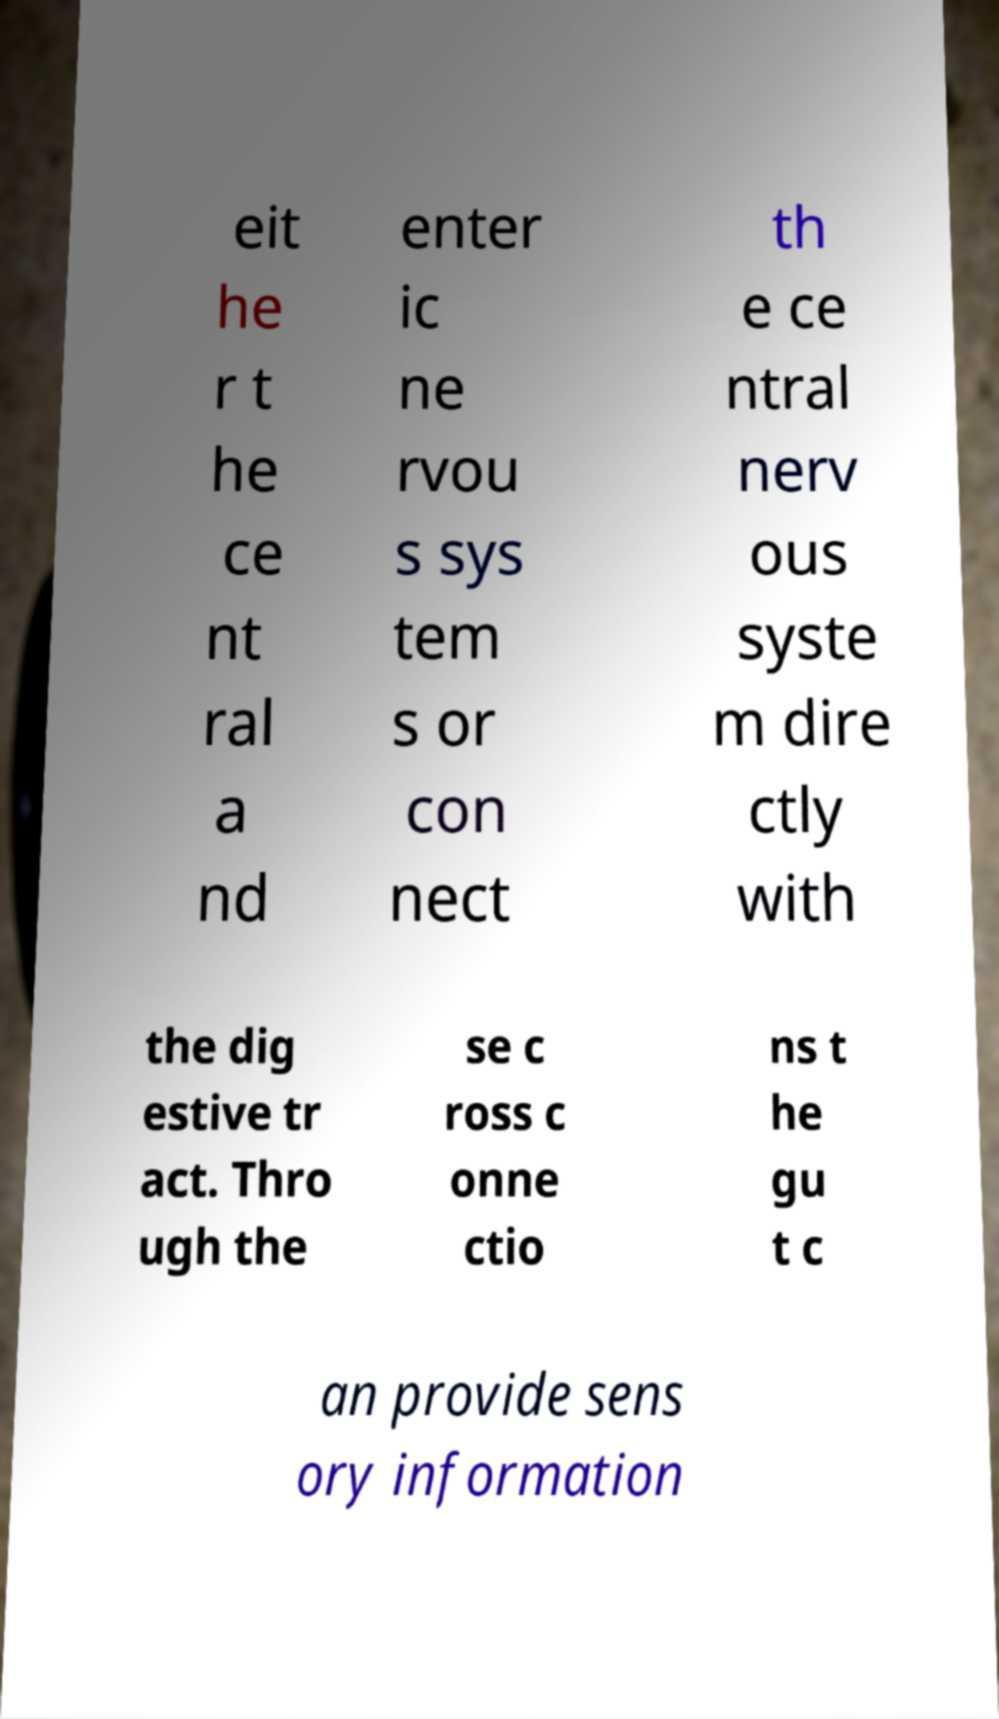Could you assist in decoding the text presented in this image and type it out clearly? eit he r t he ce nt ral a nd enter ic ne rvou s sys tem s or con nect th e ce ntral nerv ous syste m dire ctly with the dig estive tr act. Thro ugh the se c ross c onne ctio ns t he gu t c an provide sens ory information 